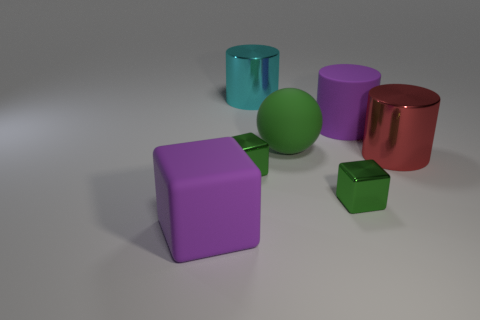Are the red thing and the tiny green thing that is right of the cyan metallic cylinder made of the same material?
Your answer should be very brief. Yes. Is the number of green objects to the right of the cyan shiny object greater than the number of cyan cylinders behind the large purple rubber cube?
Your answer should be very brief. Yes. What is the shape of the big red metallic thing?
Keep it short and to the point. Cylinder. Is the material of the green thing to the left of the big green rubber ball the same as the green object behind the red thing?
Offer a terse response. No. There is a big rubber object on the left side of the green sphere; what shape is it?
Provide a short and direct response. Cube. Is the big rubber ball the same color as the big rubber block?
Provide a short and direct response. No. Are there any other things that have the same shape as the big green matte thing?
Your answer should be very brief. No. There is a big sphere behind the big purple cube; is there a big purple matte cube that is to the right of it?
Your answer should be very brief. No. There is a big matte object that is the same shape as the large red shiny thing; what color is it?
Make the answer very short. Purple. What number of large matte things are the same color as the matte ball?
Offer a very short reply. 0. 